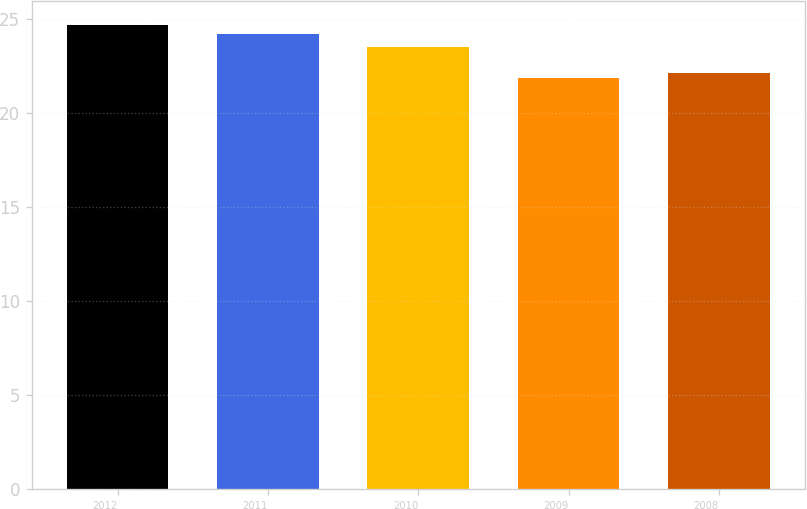Convert chart to OTSL. <chart><loc_0><loc_0><loc_500><loc_500><bar_chart><fcel>2012<fcel>2011<fcel>2010<fcel>2009<fcel>2008<nl><fcel>24.7<fcel>24.18<fcel>23.5<fcel>21.84<fcel>22.13<nl></chart> 